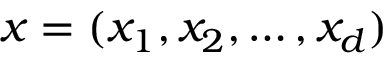Convert formula to latex. <formula><loc_0><loc_0><loc_500><loc_500>{ x } = ( x _ { 1 } , x _ { 2 } , \dots , x _ { d } )</formula> 